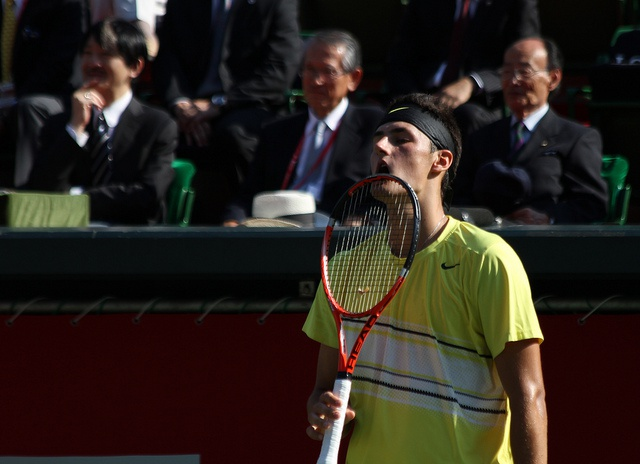Describe the objects in this image and their specific colors. I can see people in black, darkgreen, gray, and maroon tones, people in black, gray, and purple tones, people in black, maroon, gray, and lightgray tones, people in black, brown, and maroon tones, and people in black, maroon, gray, and navy tones in this image. 